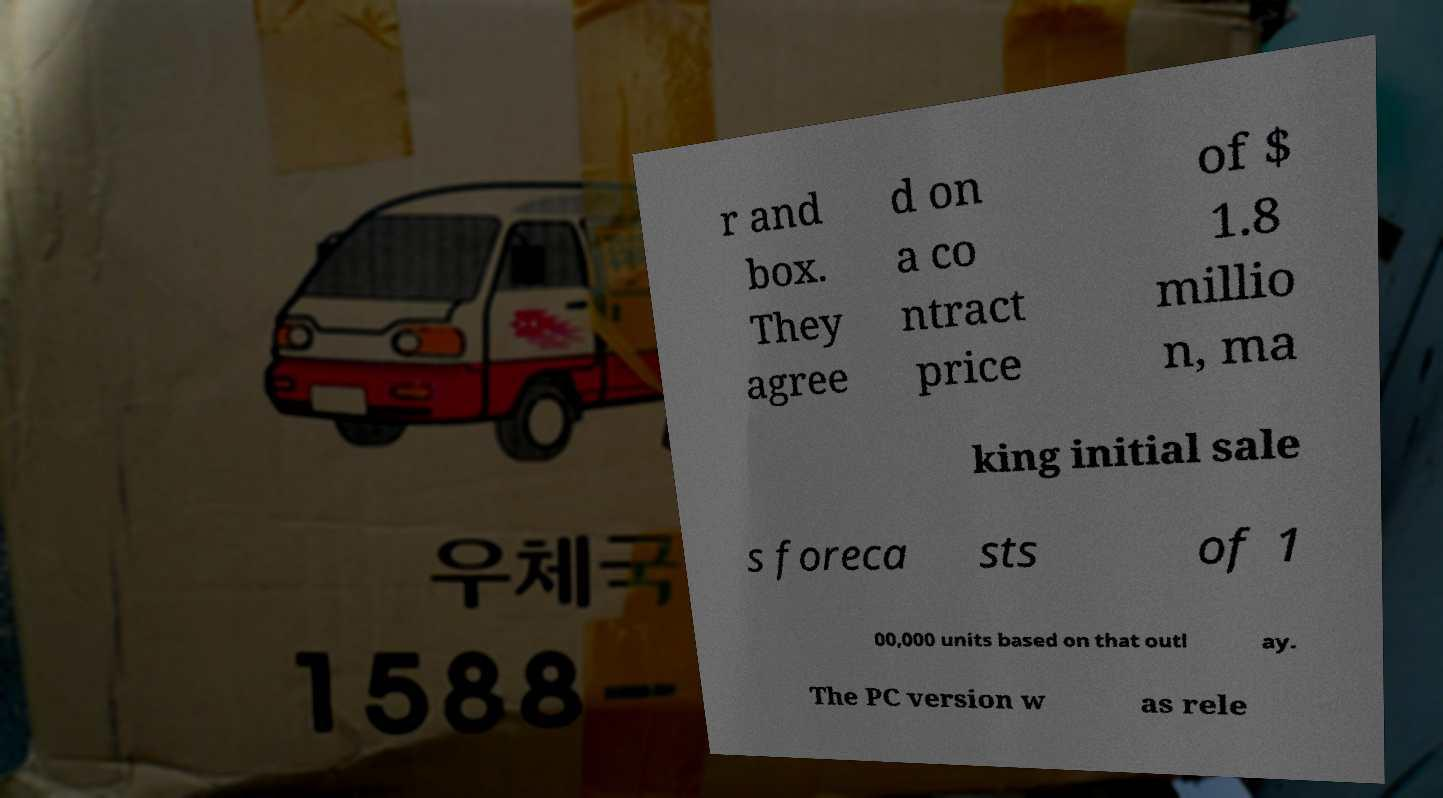Can you accurately transcribe the text from the provided image for me? r and box. They agree d on a co ntract price of $ 1.8 millio n, ma king initial sale s foreca sts of 1 00,000 units based on that outl ay. The PC version w as rele 